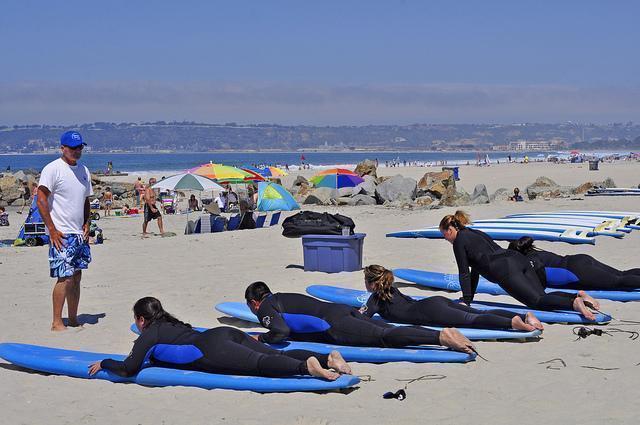What are the people on the blue boards doing?
Select the accurate response from the four choices given to answer the question.
Options: Sleeping, eating, practicing, tanning. Practicing. 